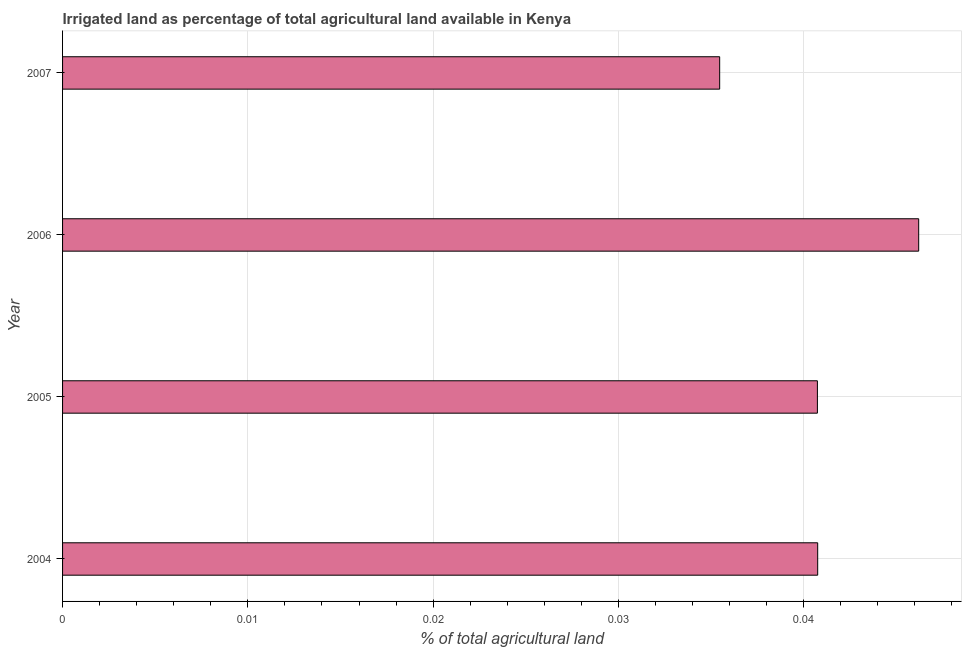What is the title of the graph?
Your answer should be very brief. Irrigated land as percentage of total agricultural land available in Kenya. What is the label or title of the X-axis?
Your response must be concise. % of total agricultural land. What is the label or title of the Y-axis?
Your answer should be very brief. Year. What is the percentage of agricultural irrigated land in 2005?
Keep it short and to the point. 0.04. Across all years, what is the maximum percentage of agricultural irrigated land?
Your answer should be compact. 0.05. Across all years, what is the minimum percentage of agricultural irrigated land?
Provide a short and direct response. 0.04. In which year was the percentage of agricultural irrigated land maximum?
Your answer should be very brief. 2006. What is the sum of the percentage of agricultural irrigated land?
Offer a very short reply. 0.16. What is the difference between the percentage of agricultural irrigated land in 2004 and 2007?
Your answer should be very brief. 0.01. What is the average percentage of agricultural irrigated land per year?
Make the answer very short. 0.04. What is the median percentage of agricultural irrigated land?
Provide a succinct answer. 0.04. What is the ratio of the percentage of agricultural irrigated land in 2004 to that in 2006?
Your answer should be very brief. 0.88. What is the difference between the highest and the second highest percentage of agricultural irrigated land?
Your response must be concise. 0.01. Is the sum of the percentage of agricultural irrigated land in 2004 and 2007 greater than the maximum percentage of agricultural irrigated land across all years?
Ensure brevity in your answer.  Yes. What is the difference between the highest and the lowest percentage of agricultural irrigated land?
Offer a terse response. 0.01. In how many years, is the percentage of agricultural irrigated land greater than the average percentage of agricultural irrigated land taken over all years?
Your answer should be very brief. 1. How many years are there in the graph?
Offer a terse response. 4. What is the difference between two consecutive major ticks on the X-axis?
Provide a succinct answer. 0.01. What is the % of total agricultural land of 2004?
Keep it short and to the point. 0.04. What is the % of total agricultural land in 2005?
Provide a succinct answer. 0.04. What is the % of total agricultural land of 2006?
Provide a succinct answer. 0.05. What is the % of total agricultural land in 2007?
Your response must be concise. 0.04. What is the difference between the % of total agricultural land in 2004 and 2005?
Your response must be concise. 2e-5. What is the difference between the % of total agricultural land in 2004 and 2006?
Your response must be concise. -0.01. What is the difference between the % of total agricultural land in 2004 and 2007?
Provide a succinct answer. 0.01. What is the difference between the % of total agricultural land in 2005 and 2006?
Ensure brevity in your answer.  -0.01. What is the difference between the % of total agricultural land in 2005 and 2007?
Provide a succinct answer. 0.01. What is the difference between the % of total agricultural land in 2006 and 2007?
Offer a very short reply. 0.01. What is the ratio of the % of total agricultural land in 2004 to that in 2006?
Your response must be concise. 0.88. What is the ratio of the % of total agricultural land in 2004 to that in 2007?
Your answer should be compact. 1.15. What is the ratio of the % of total agricultural land in 2005 to that in 2006?
Give a very brief answer. 0.88. What is the ratio of the % of total agricultural land in 2005 to that in 2007?
Make the answer very short. 1.15. What is the ratio of the % of total agricultural land in 2006 to that in 2007?
Provide a succinct answer. 1.3. 